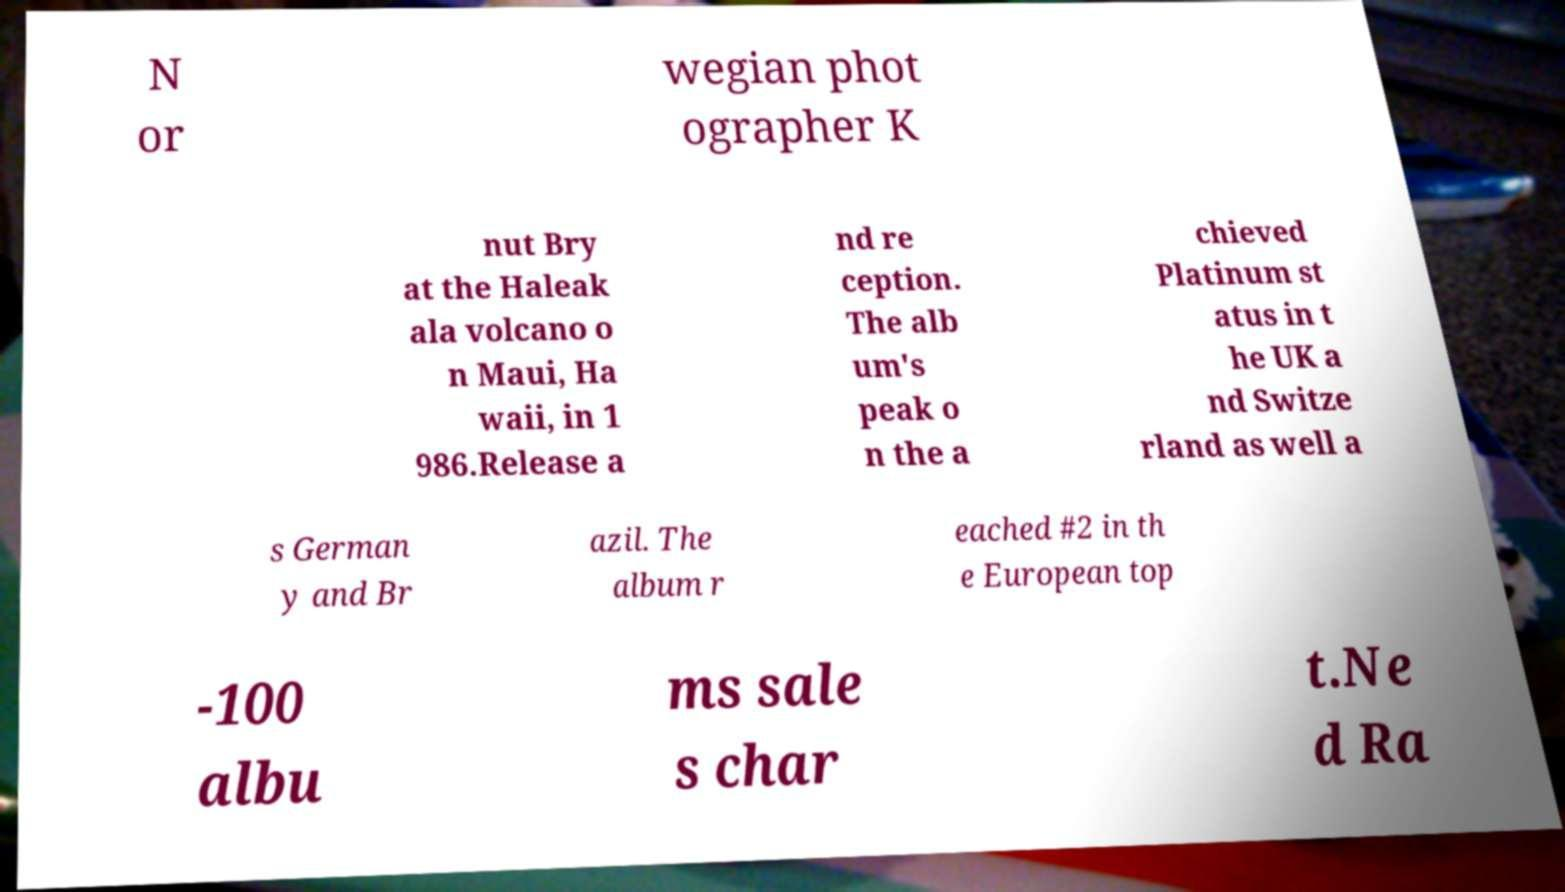There's text embedded in this image that I need extracted. Can you transcribe it verbatim? N or wegian phot ographer K nut Bry at the Haleak ala volcano o n Maui, Ha waii, in 1 986.Release a nd re ception. The alb um's peak o n the a chieved Platinum st atus in t he UK a nd Switze rland as well a s German y and Br azil. The album r eached #2 in th e European top -100 albu ms sale s char t.Ne d Ra 